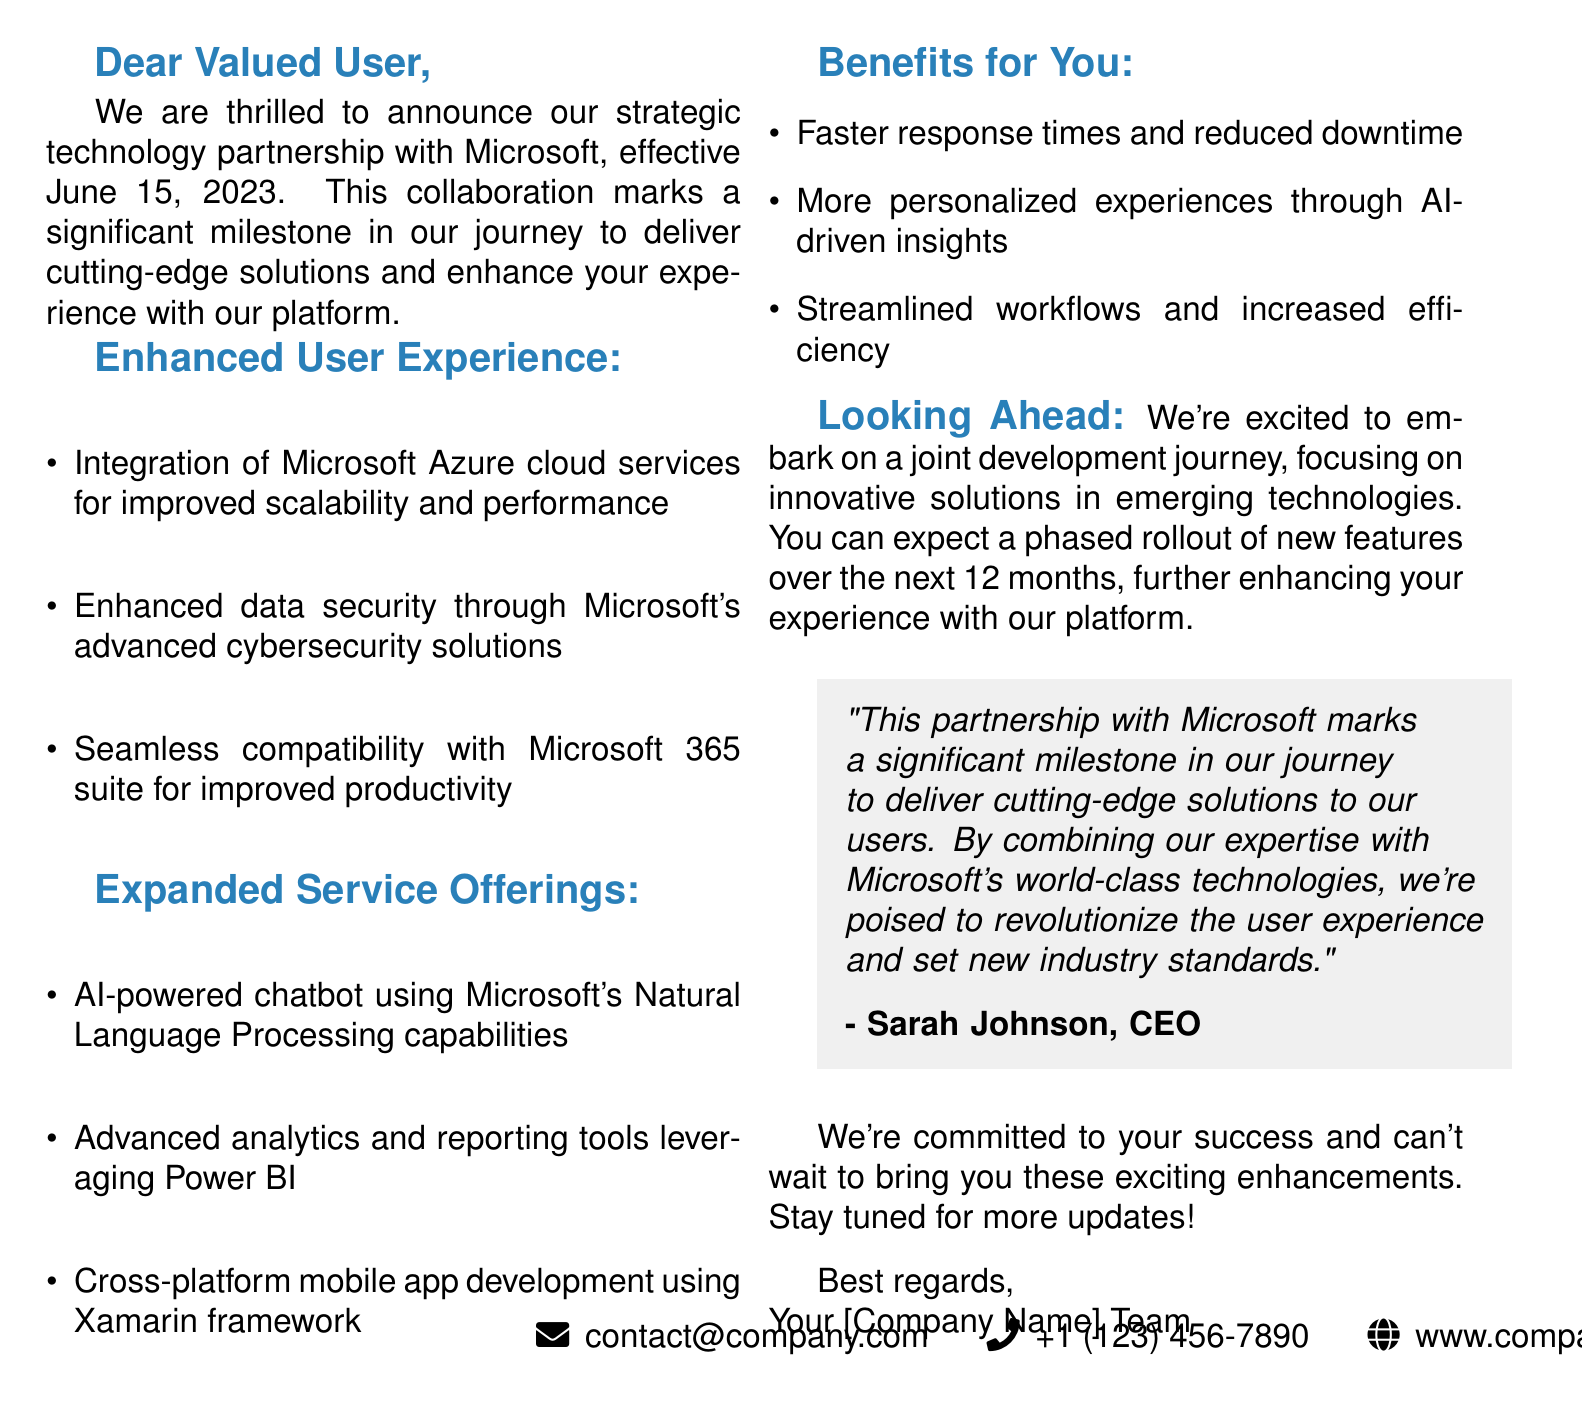What is the partner company? The partnership is specifically with Microsoft, as stated in the document.
Answer: Microsoft When was the partnership announced? The announcement date is clearly mentioned in the document.
Answer: June 15, 2023 What type of partnership is this? The document specifies that this is a strategic technology partnership.
Answer: Strategic Technology Partnership What will be integrated for improved scalability and performance? The document lists Microsoft Azure cloud services as the integration for scalability.
Answer: Microsoft Azure cloud services What benefits can users expect from this partnership? The document outlines several benefits, including faster response times.
Answer: Faster response times and reduced downtime What is one of the new service offerings mentioned? The document details new services, including an AI-powered chatbot.
Answer: AI-powered chatbot Who is the speaker quoted in the document? The quote in the document attributes the statement to the CEO.
Answer: Sarah Johnson What is the timeline for the rollout of new features? The document discusses a phased rollout planned over the next 12 months.
Answer: 12 months What does the quote highlight about the partnership? The document's quote emphasizes the significance of combining expertise with Microsoft's technologies.
Answer: Significant milestone 